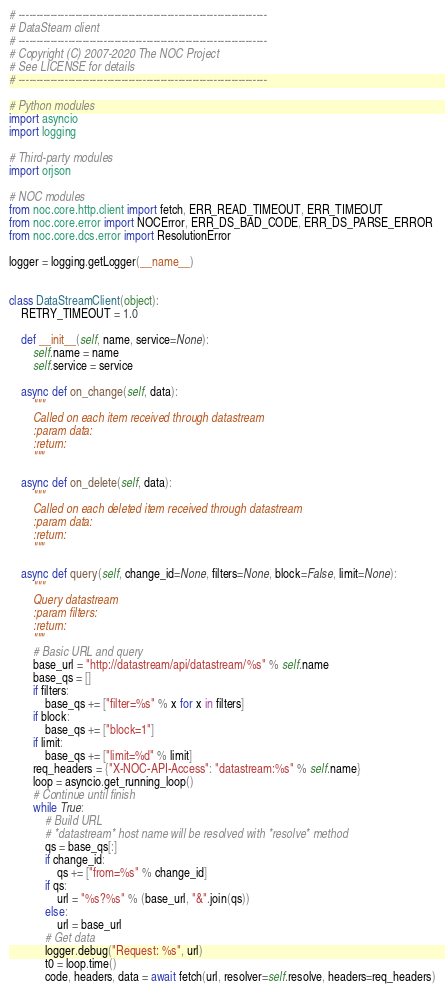Convert code to text. <code><loc_0><loc_0><loc_500><loc_500><_Python_># ----------------------------------------------------------------------
# DataSteam client
# ----------------------------------------------------------------------
# Copyright (C) 2007-2020 The NOC Project
# See LICENSE for details
# ----------------------------------------------------------------------

# Python modules
import asyncio
import logging

# Third-party modules
import orjson

# NOC modules
from noc.core.http.client import fetch, ERR_READ_TIMEOUT, ERR_TIMEOUT
from noc.core.error import NOCError, ERR_DS_BAD_CODE, ERR_DS_PARSE_ERROR
from noc.core.dcs.error import ResolutionError

logger = logging.getLogger(__name__)


class DataStreamClient(object):
    RETRY_TIMEOUT = 1.0

    def __init__(self, name, service=None):
        self.name = name
        self.service = service

    async def on_change(self, data):
        """
        Called on each item received through datastream
        :param data:
        :return:
        """

    async def on_delete(self, data):
        """
        Called on each deleted item received through datastream
        :param data:
        :return:
        """

    async def query(self, change_id=None, filters=None, block=False, limit=None):
        """
        Query datastream
        :param filters:
        :return:
        """
        # Basic URL and query
        base_url = "http://datastream/api/datastream/%s" % self.name
        base_qs = []
        if filters:
            base_qs += ["filter=%s" % x for x in filters]
        if block:
            base_qs += ["block=1"]
        if limit:
            base_qs += ["limit=%d" % limit]
        req_headers = {"X-NOC-API-Access": "datastream:%s" % self.name}
        loop = asyncio.get_running_loop()
        # Continue until finish
        while True:
            # Build URL
            # *datastream* host name will be resolved with *resolve* method
            qs = base_qs[:]
            if change_id:
                qs += ["from=%s" % change_id]
            if qs:
                url = "%s?%s" % (base_url, "&".join(qs))
            else:
                url = base_url
            # Get data
            logger.debug("Request: %s", url)
            t0 = loop.time()
            code, headers, data = await fetch(url, resolver=self.resolve, headers=req_headers)</code> 